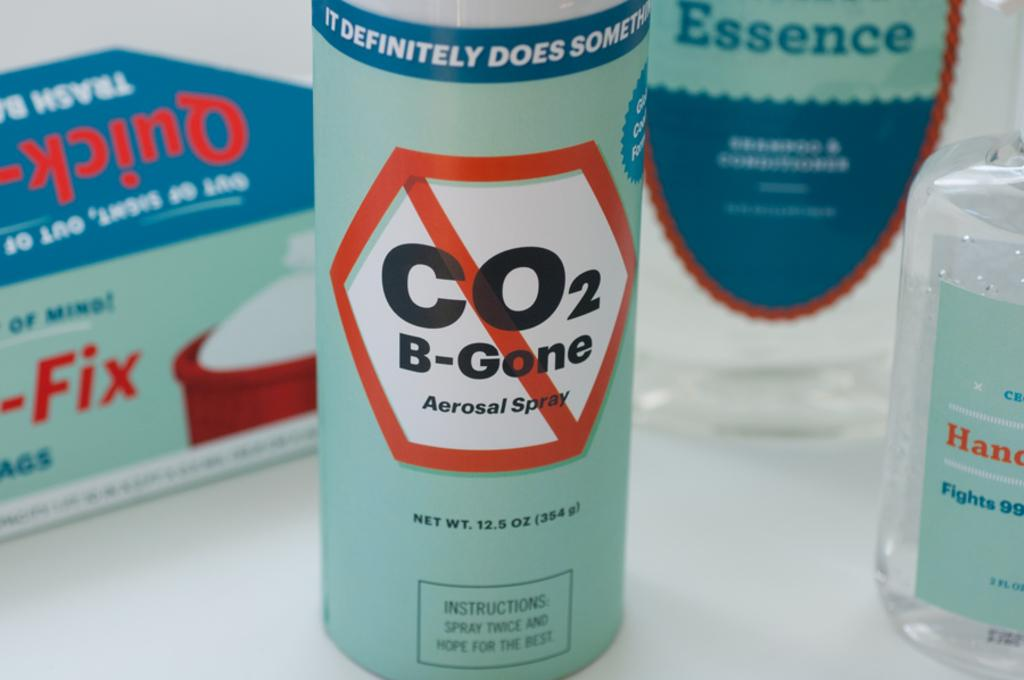<image>
Give a short and clear explanation of the subsequent image. Bottle  of spray that says CO2 B-Gone. 